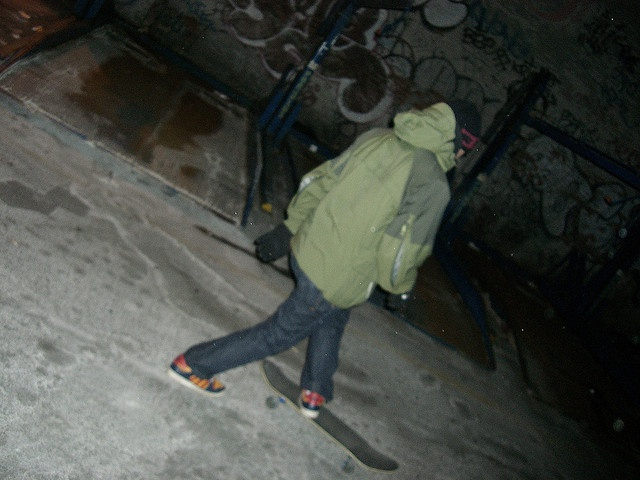Describe the objects in this image and their specific colors. I can see people in black and gray tones and skateboard in black and gray tones in this image. 